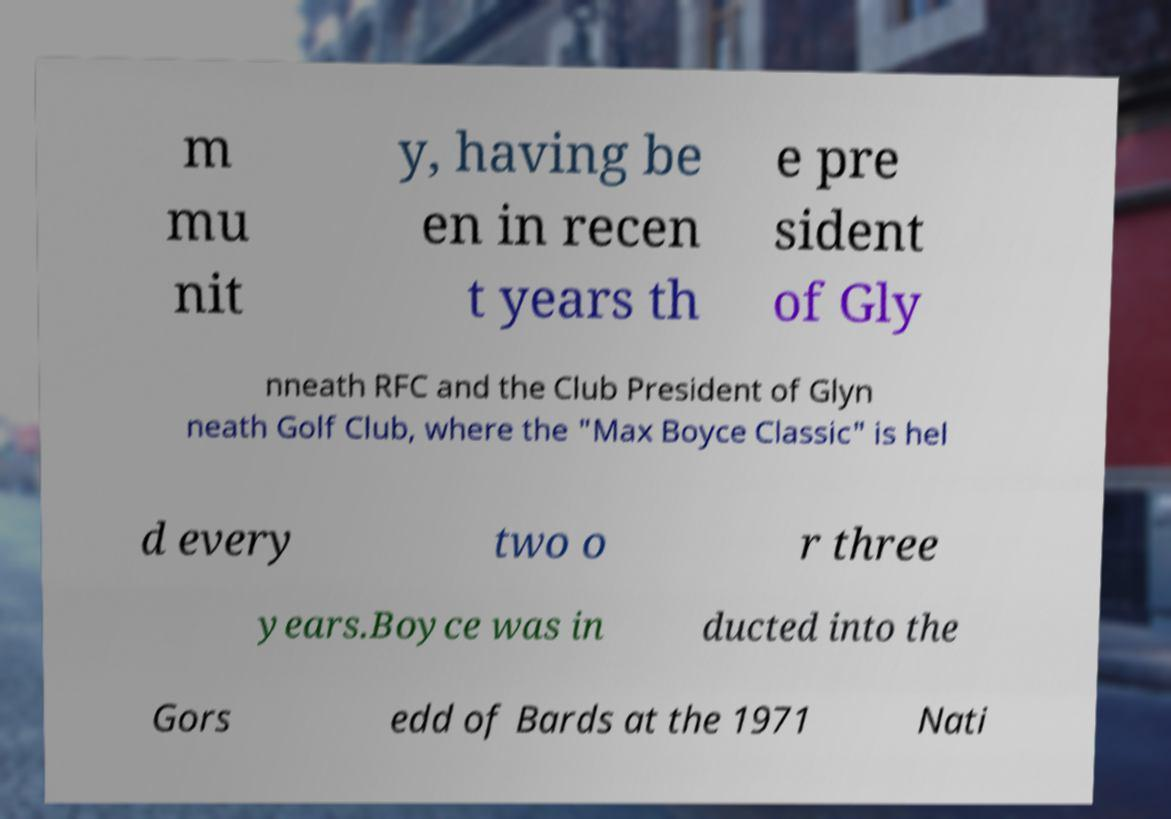There's text embedded in this image that I need extracted. Can you transcribe it verbatim? m mu nit y, having be en in recen t years th e pre sident of Gly nneath RFC and the Club President of Glyn neath Golf Club, where the "Max Boyce Classic" is hel d every two o r three years.Boyce was in ducted into the Gors edd of Bards at the 1971 Nati 